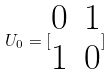<formula> <loc_0><loc_0><loc_500><loc_500>U _ { 0 } = [ \begin{matrix} 0 & 1 \\ 1 & 0 \end{matrix} ]</formula> 